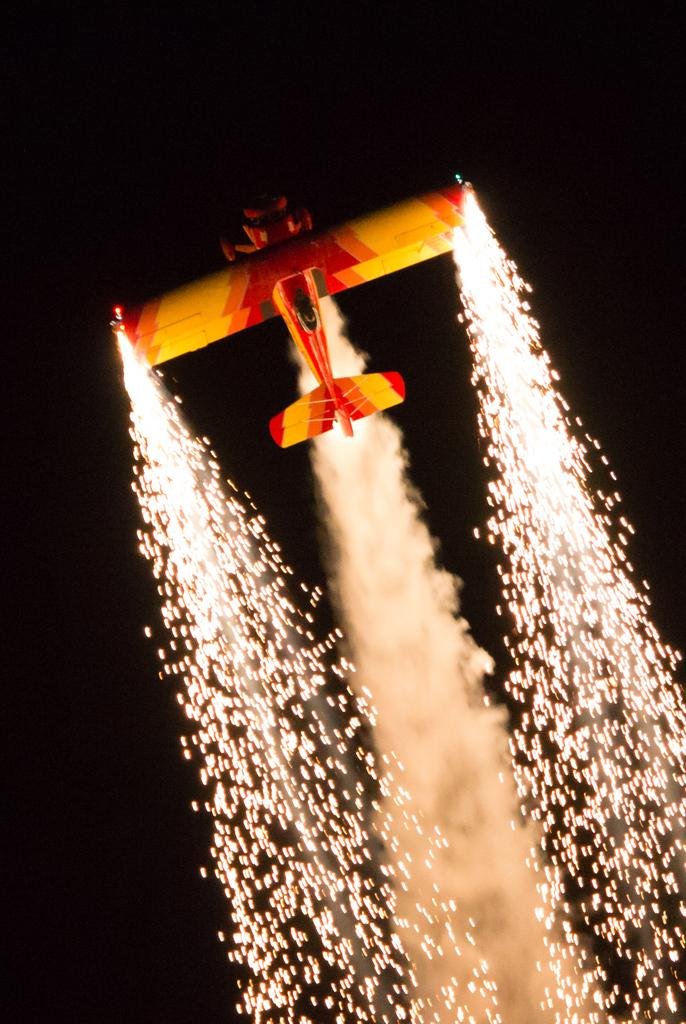What time of day was the image taken? The image was taken during night time. What is the main subject in the center of the image? There is a glider in the center of the image. What additional feature can be seen in the image? Fireworks are present in the image. What else is visible in the image? Smoke is visible in the image. Can you see a squirrel climbing the bridge in the image? There is no squirrel or bridge present in the image. What type of bird can be seen flying near the glider in the image? There are no birds visible in the image; it only features a glider, fireworks, smoke, and the night sky. 